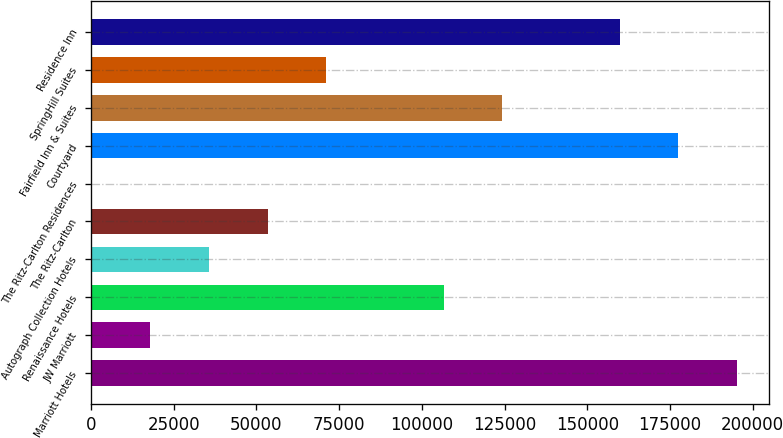Convert chart. <chart><loc_0><loc_0><loc_500><loc_500><bar_chart><fcel>Marriott Hotels<fcel>JW Marriott<fcel>Renaissance Hotels<fcel>Autograph Collection Hotels<fcel>The Ritz-Carlton<fcel>The Ritz-Carlton Residences<fcel>Courtyard<fcel>Fairfield Inn & Suites<fcel>SpringHill Suites<fcel>Residence Inn<nl><fcel>195273<fcel>17946.6<fcel>106610<fcel>35679.2<fcel>53411.8<fcel>214<fcel>177540<fcel>124342<fcel>71144.4<fcel>159807<nl></chart> 